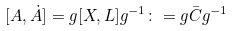Convert formula to latex. <formula><loc_0><loc_0><loc_500><loc_500>[ A , \dot { A } ] = g [ X , L ] g ^ { - 1 } \colon = g \bar { C } g ^ { - 1 }</formula> 